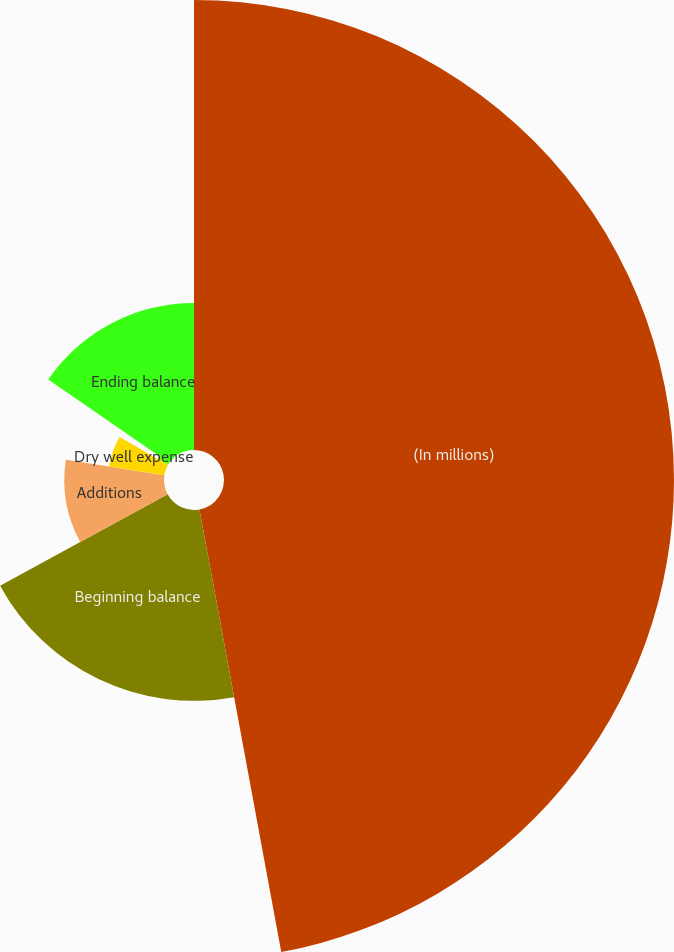Convert chart. <chart><loc_0><loc_0><loc_500><loc_500><pie_chart><fcel>(In millions)<fcel>Beginning balance<fcel>Additions<fcel>Dry well expense<fcel>Transfers to development<fcel>Ending balance<nl><fcel>47.09%<fcel>19.97%<fcel>10.43%<fcel>5.85%<fcel>1.27%<fcel>15.39%<nl></chart> 